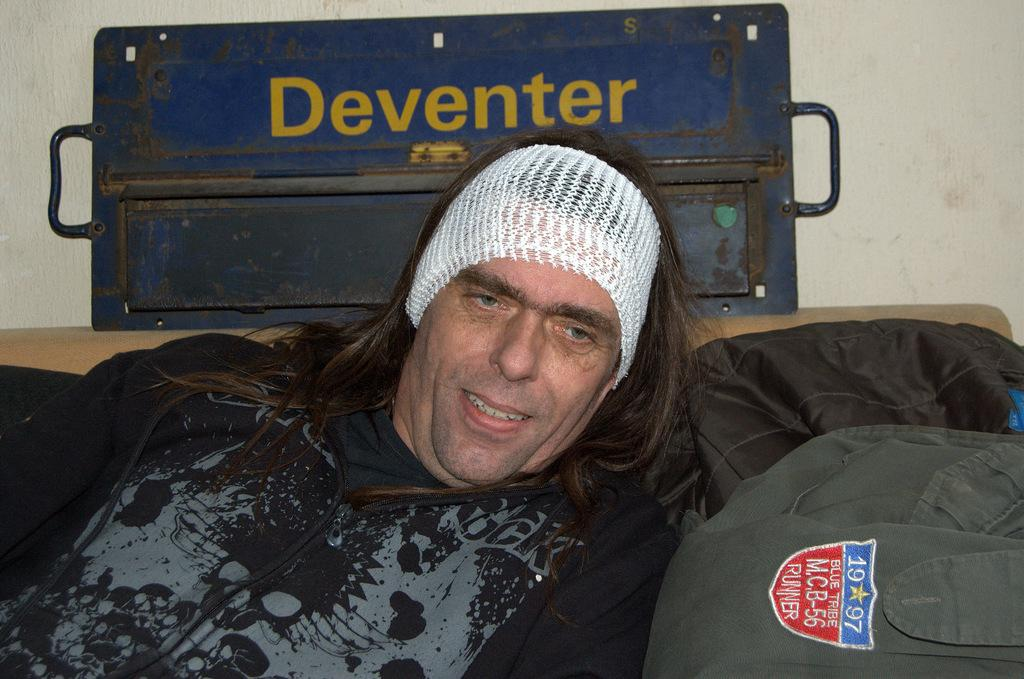Who is present in the image? There is a man in the image. What is the man wearing? The man is wearing a black coat and a white hair band. What object can be seen behind the man? There is an iron box behind the man. What type of vegetable is the man holding in the image? There is no vegetable present in the image; the man is not holding anything. 